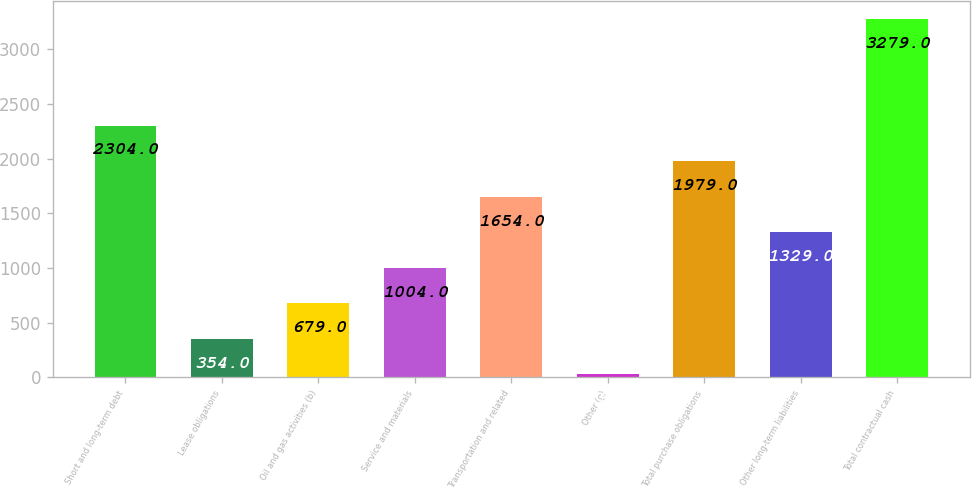Convert chart to OTSL. <chart><loc_0><loc_0><loc_500><loc_500><bar_chart><fcel>Short and long-term debt<fcel>Lease obligations<fcel>Oil and gas activities (b)<fcel>Service and materials<fcel>Transportation and related<fcel>Other (g)<fcel>Total purchase obligations<fcel>Other long-term liabilities<fcel>Total contractual cash<nl><fcel>2304<fcel>354<fcel>679<fcel>1004<fcel>1654<fcel>29<fcel>1979<fcel>1329<fcel>3279<nl></chart> 